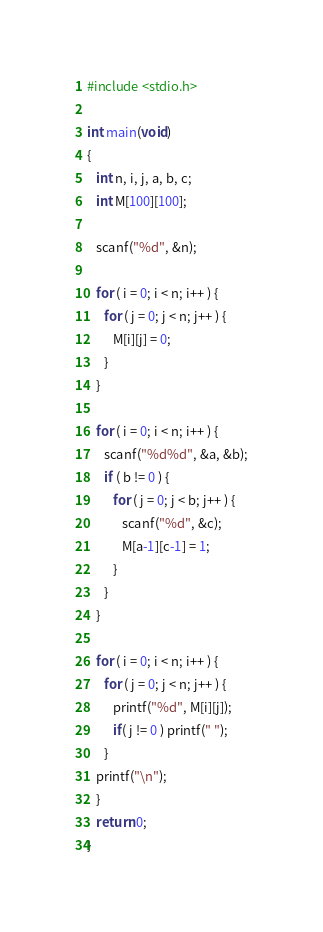Convert code to text. <code><loc_0><loc_0><loc_500><loc_500><_C_>#include <stdio.h>

int main(void)
{
   int n, i, j, a, b, c;
   int M[100][100];

   scanf("%d", &n);

   for ( i = 0; i < n; i++ ) {
      for ( j = 0; j < n; j++ ) {
         M[i][j] = 0;
      }
   }

   for ( i = 0; i < n; i++ ) {
      scanf("%d%d", &a, &b);
      if ( b != 0 ) {
         for ( j = 0; j < b; j++ ) {
            scanf("%d", &c);
            M[a-1][c-1] = 1;
         }
      }
   }

   for ( i = 0; i < n; i++ ) {
      for ( j = 0; j < n; j++ ) {
         printf("%d", M[i][j]);
         if( j != 0 ) printf(" ");
      }
   printf("\n");
   }
   return 0;
}</code> 